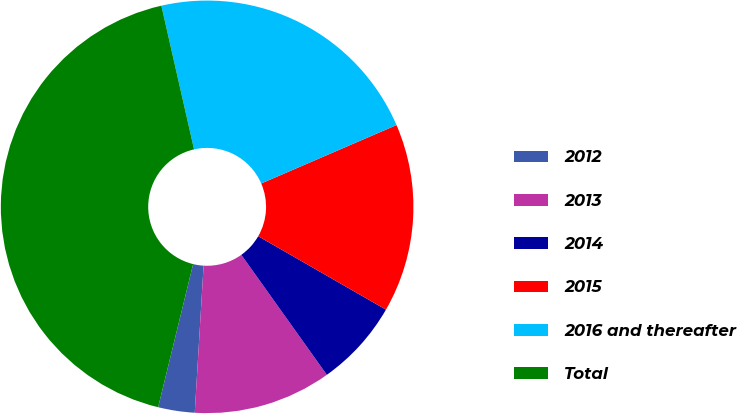<chart> <loc_0><loc_0><loc_500><loc_500><pie_chart><fcel>2012<fcel>2013<fcel>2014<fcel>2015<fcel>2016 and thereafter<fcel>Total<nl><fcel>2.86%<fcel>10.81%<fcel>6.84%<fcel>14.79%<fcel>22.07%<fcel>42.62%<nl></chart> 